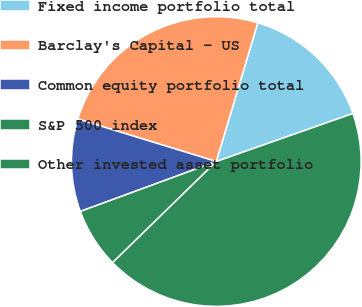<chart> <loc_0><loc_0><loc_500><loc_500><pie_chart><fcel>Fixed income portfolio total<fcel>Barclay's Capital - US<fcel>Common equity portfolio total<fcel>S&P 500 index<fcel>Other invested asset portfolio<nl><fcel>15.0%<fcel>24.89%<fcel>10.34%<fcel>6.7%<fcel>43.08%<nl></chart> 